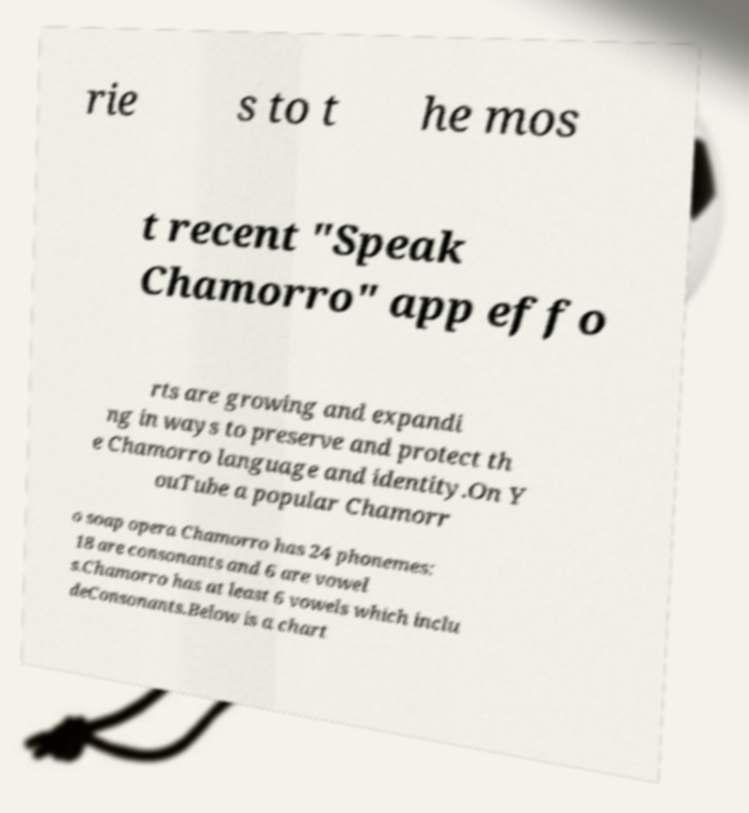Can you accurately transcribe the text from the provided image for me? rie s to t he mos t recent "Speak Chamorro" app effo rts are growing and expandi ng in ways to preserve and protect th e Chamorro language and identity.On Y ouTube a popular Chamorr o soap opera Chamorro has 24 phonemes: 18 are consonants and 6 are vowel s.Chamorro has at least 6 vowels which inclu deConsonants.Below is a chart 